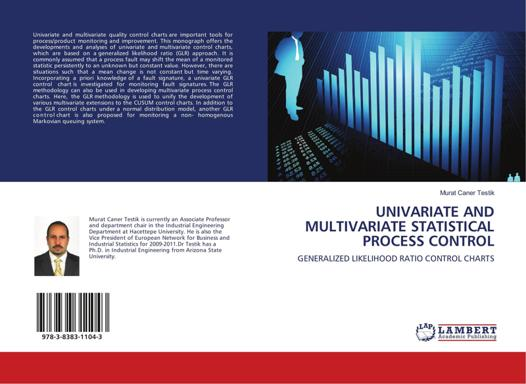Can you explain who might find this book useful and why? This book is particularly valuable for professionals and students in the fields of industrial engineering, quality control, and manufacturing. Its in-depth focus on statistical process control techniques makes it an essential resource for anyone involved in overseeing or improving manufacturing and production processes. The methods discussed are vital for maintaining high standards of quality and efficiency in any product-oriented business. 